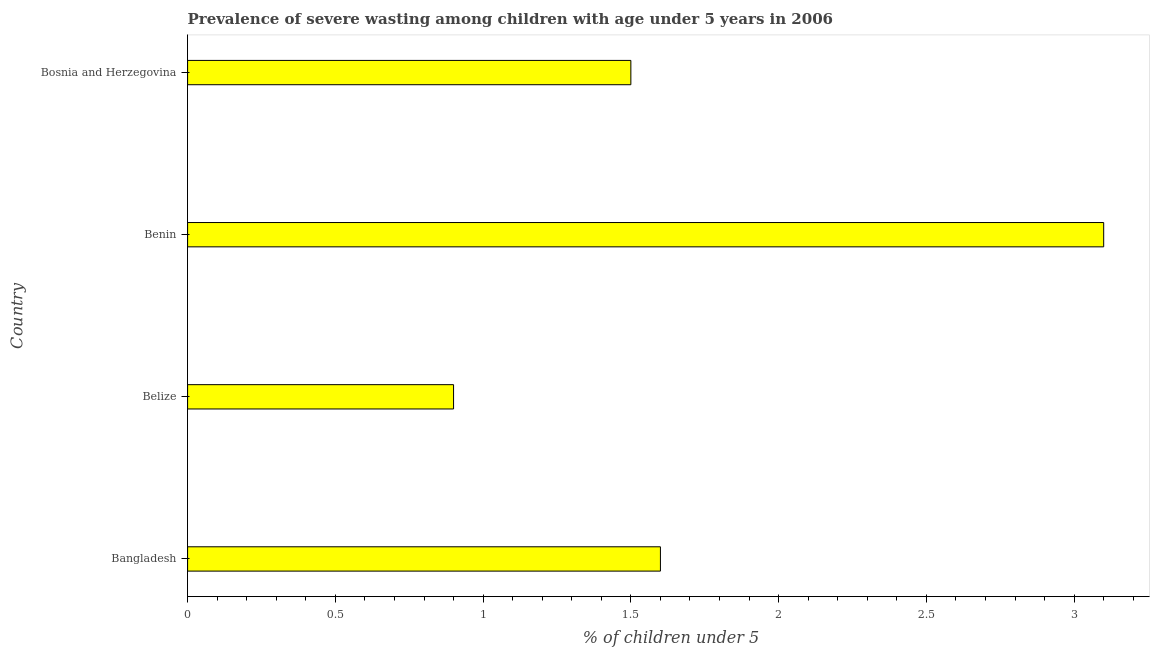What is the title of the graph?
Your answer should be compact. Prevalence of severe wasting among children with age under 5 years in 2006. What is the label or title of the X-axis?
Your answer should be compact.  % of children under 5. What is the label or title of the Y-axis?
Your answer should be very brief. Country. What is the prevalence of severe wasting in Bosnia and Herzegovina?
Give a very brief answer. 1.5. Across all countries, what is the maximum prevalence of severe wasting?
Offer a terse response. 3.1. Across all countries, what is the minimum prevalence of severe wasting?
Offer a very short reply. 0.9. In which country was the prevalence of severe wasting maximum?
Ensure brevity in your answer.  Benin. In which country was the prevalence of severe wasting minimum?
Offer a very short reply. Belize. What is the sum of the prevalence of severe wasting?
Provide a short and direct response. 7.1. What is the average prevalence of severe wasting per country?
Offer a very short reply. 1.77. What is the median prevalence of severe wasting?
Give a very brief answer. 1.55. What is the ratio of the prevalence of severe wasting in Belize to that in Benin?
Your answer should be very brief. 0.29. Is the difference between the prevalence of severe wasting in Bangladesh and Bosnia and Herzegovina greater than the difference between any two countries?
Your answer should be very brief. No. What is the difference between the highest and the second highest prevalence of severe wasting?
Your answer should be very brief. 1.5. Is the sum of the prevalence of severe wasting in Bangladesh and Benin greater than the maximum prevalence of severe wasting across all countries?
Your answer should be compact. Yes. What is the difference between the highest and the lowest prevalence of severe wasting?
Keep it short and to the point. 2.2. In how many countries, is the prevalence of severe wasting greater than the average prevalence of severe wasting taken over all countries?
Provide a succinct answer. 1. Are all the bars in the graph horizontal?
Keep it short and to the point. Yes. What is the  % of children under 5 in Bangladesh?
Your answer should be very brief. 1.6. What is the  % of children under 5 in Belize?
Provide a succinct answer. 0.9. What is the  % of children under 5 in Benin?
Offer a very short reply. 3.1. What is the  % of children under 5 in Bosnia and Herzegovina?
Offer a terse response. 1.5. What is the difference between the  % of children under 5 in Bangladesh and Benin?
Your answer should be very brief. -1.5. What is the difference between the  % of children under 5 in Belize and Benin?
Keep it short and to the point. -2.2. What is the ratio of the  % of children under 5 in Bangladesh to that in Belize?
Offer a very short reply. 1.78. What is the ratio of the  % of children under 5 in Bangladesh to that in Benin?
Ensure brevity in your answer.  0.52. What is the ratio of the  % of children under 5 in Bangladesh to that in Bosnia and Herzegovina?
Provide a short and direct response. 1.07. What is the ratio of the  % of children under 5 in Belize to that in Benin?
Provide a short and direct response. 0.29. What is the ratio of the  % of children under 5 in Benin to that in Bosnia and Herzegovina?
Offer a terse response. 2.07. 